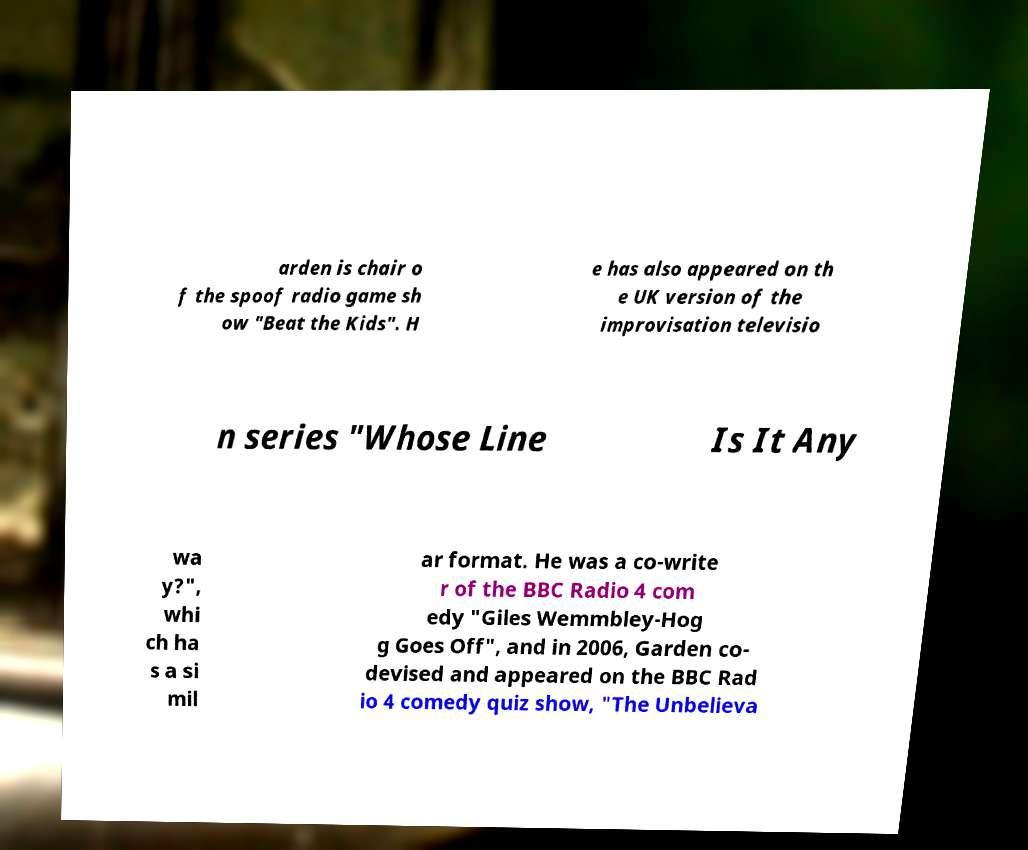Could you extract and type out the text from this image? arden is chair o f the spoof radio game sh ow "Beat the Kids". H e has also appeared on th e UK version of the improvisation televisio n series "Whose Line Is It Any wa y?", whi ch ha s a si mil ar format. He was a co-write r of the BBC Radio 4 com edy "Giles Wemmbley-Hog g Goes Off", and in 2006, Garden co- devised and appeared on the BBC Rad io 4 comedy quiz show, "The Unbelieva 